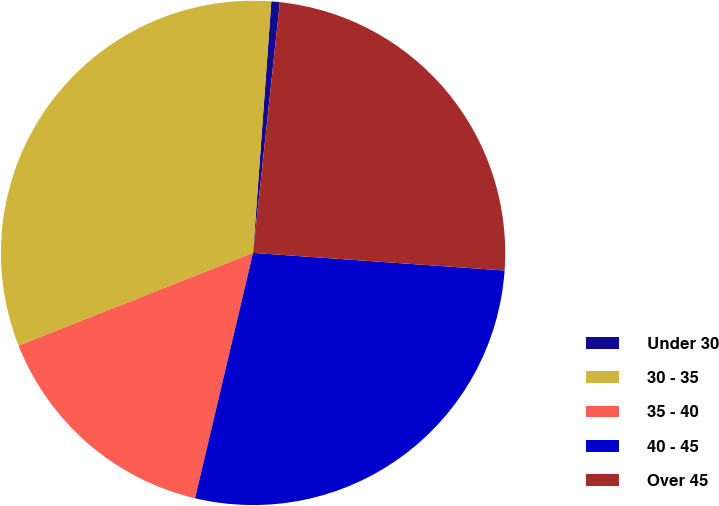Convert chart. <chart><loc_0><loc_0><loc_500><loc_500><pie_chart><fcel>Under 30<fcel>30 - 35<fcel>35 - 40<fcel>40 - 45<fcel>Over 45<nl><fcel>0.54%<fcel>32.15%<fcel>15.31%<fcel>27.58%<fcel>24.42%<nl></chart> 